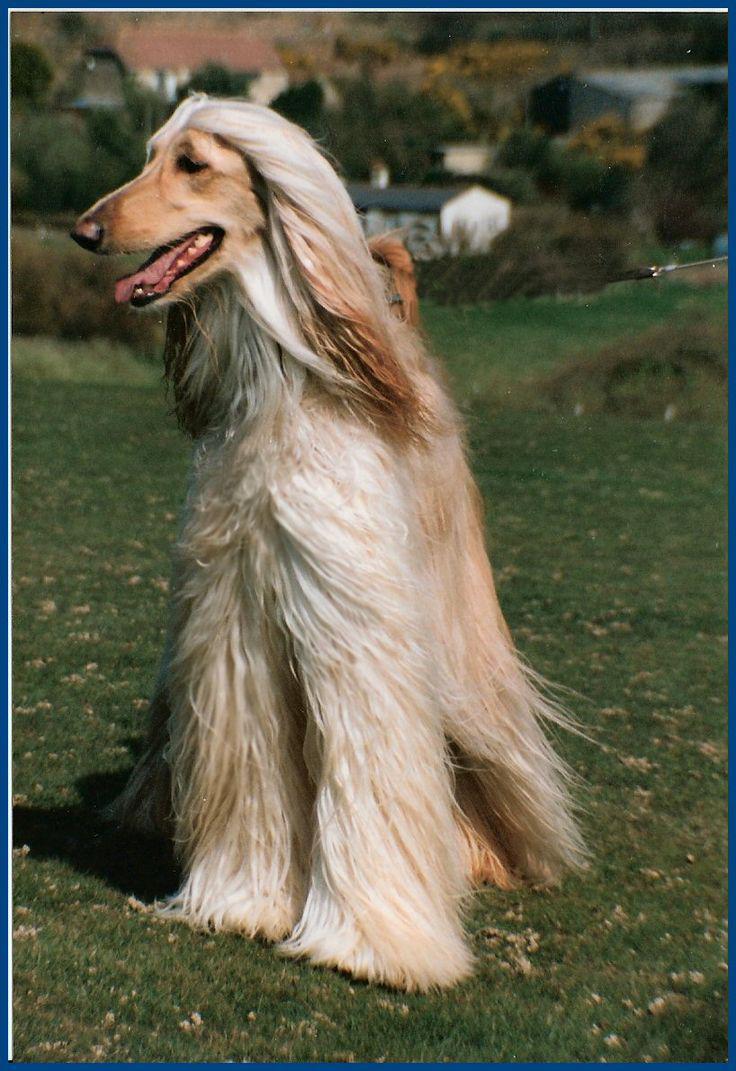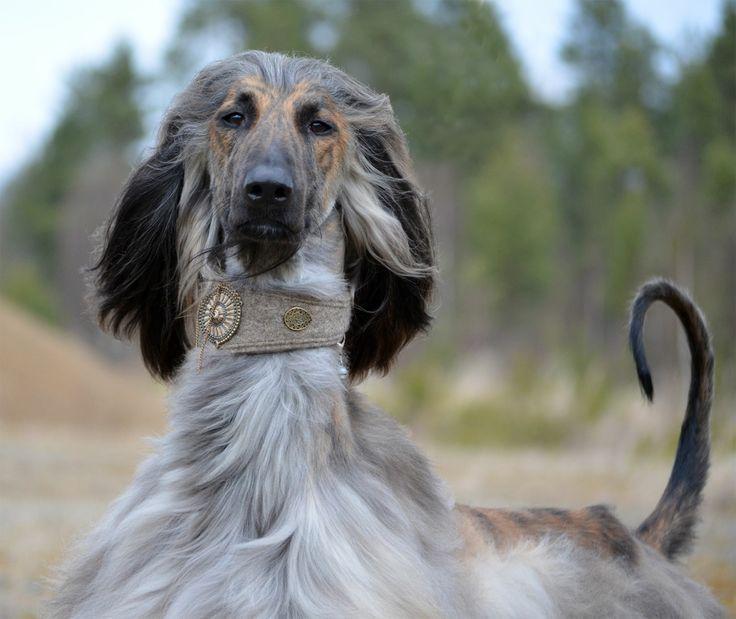The first image is the image on the left, the second image is the image on the right. For the images displayed, is the sentence "A human's arm can be seen in one of the photos." factually correct? Answer yes or no. No. The first image is the image on the left, the second image is the image on the right. Evaluate the accuracy of this statement regarding the images: "There are two dogs facing each other in the image on the right.". Is it true? Answer yes or no. No. 